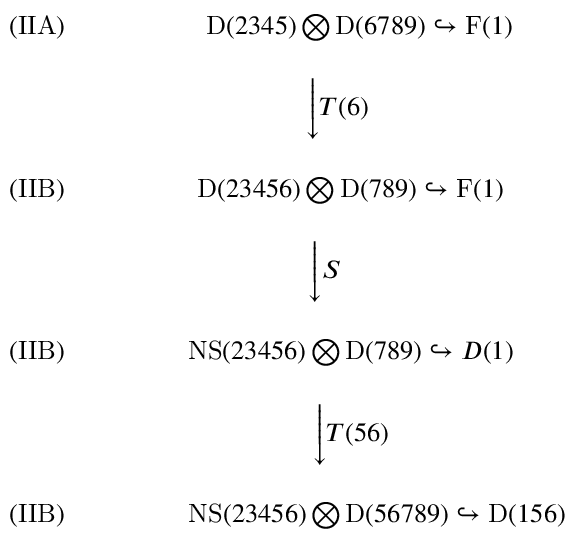Convert formula to latex. <formula><loc_0><loc_0><loc_500><loc_500>\begin{array} { c c c } { ( I I A ) \quad \ } & { \ \ D ( 2 3 4 5 ) \bigotimes D ( 6 7 8 9 ) \hookrightarrow F ( 1 ) } \\ { \ } \\ { \ } & { { \Big \downarrow { T { ( 6 ) \quad } } } } \\ { \ } \\ { ( I I B ) \quad \ } & { D ( 2 3 4 5 6 ) \bigotimes D ( 7 8 9 ) \hookrightarrow F ( 1 ) } \\ { \ } \\ { \ } & { { \Big \downarrow { S { \quad \ \ } } } } \\ { \ } \\ { ( I I B ) \quad \ } & { N S ( 2 3 4 5 6 ) \bigotimes D ( 7 8 9 ) \hookrightarrow D ( 1 ) } \\ { \ } \\ { \ } & { { \Big \downarrow { T ( 5 6 ) } } } \\ { \ } \\ { ( I I B ) \quad \ } & { \quad \ \ N S ( 2 3 4 5 6 ) \bigotimes D ( 5 6 7 8 9 ) \hookrightarrow D ( 1 5 6 ) } \end{array}</formula> 